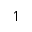Convert formula to latex. <formula><loc_0><loc_0><loc_500><loc_500>\upharpoonleft</formula> 